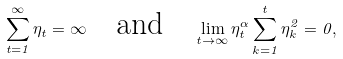<formula> <loc_0><loc_0><loc_500><loc_500>\sum _ { t = 1 } ^ { \infty } \eta _ { t } = \infty \quad \text {and} \quad \lim _ { t \to \infty } \eta _ { t } ^ { \alpha } \sum _ { k = 1 } ^ { t } \eta _ { k } ^ { 2 } = 0 ,</formula> 